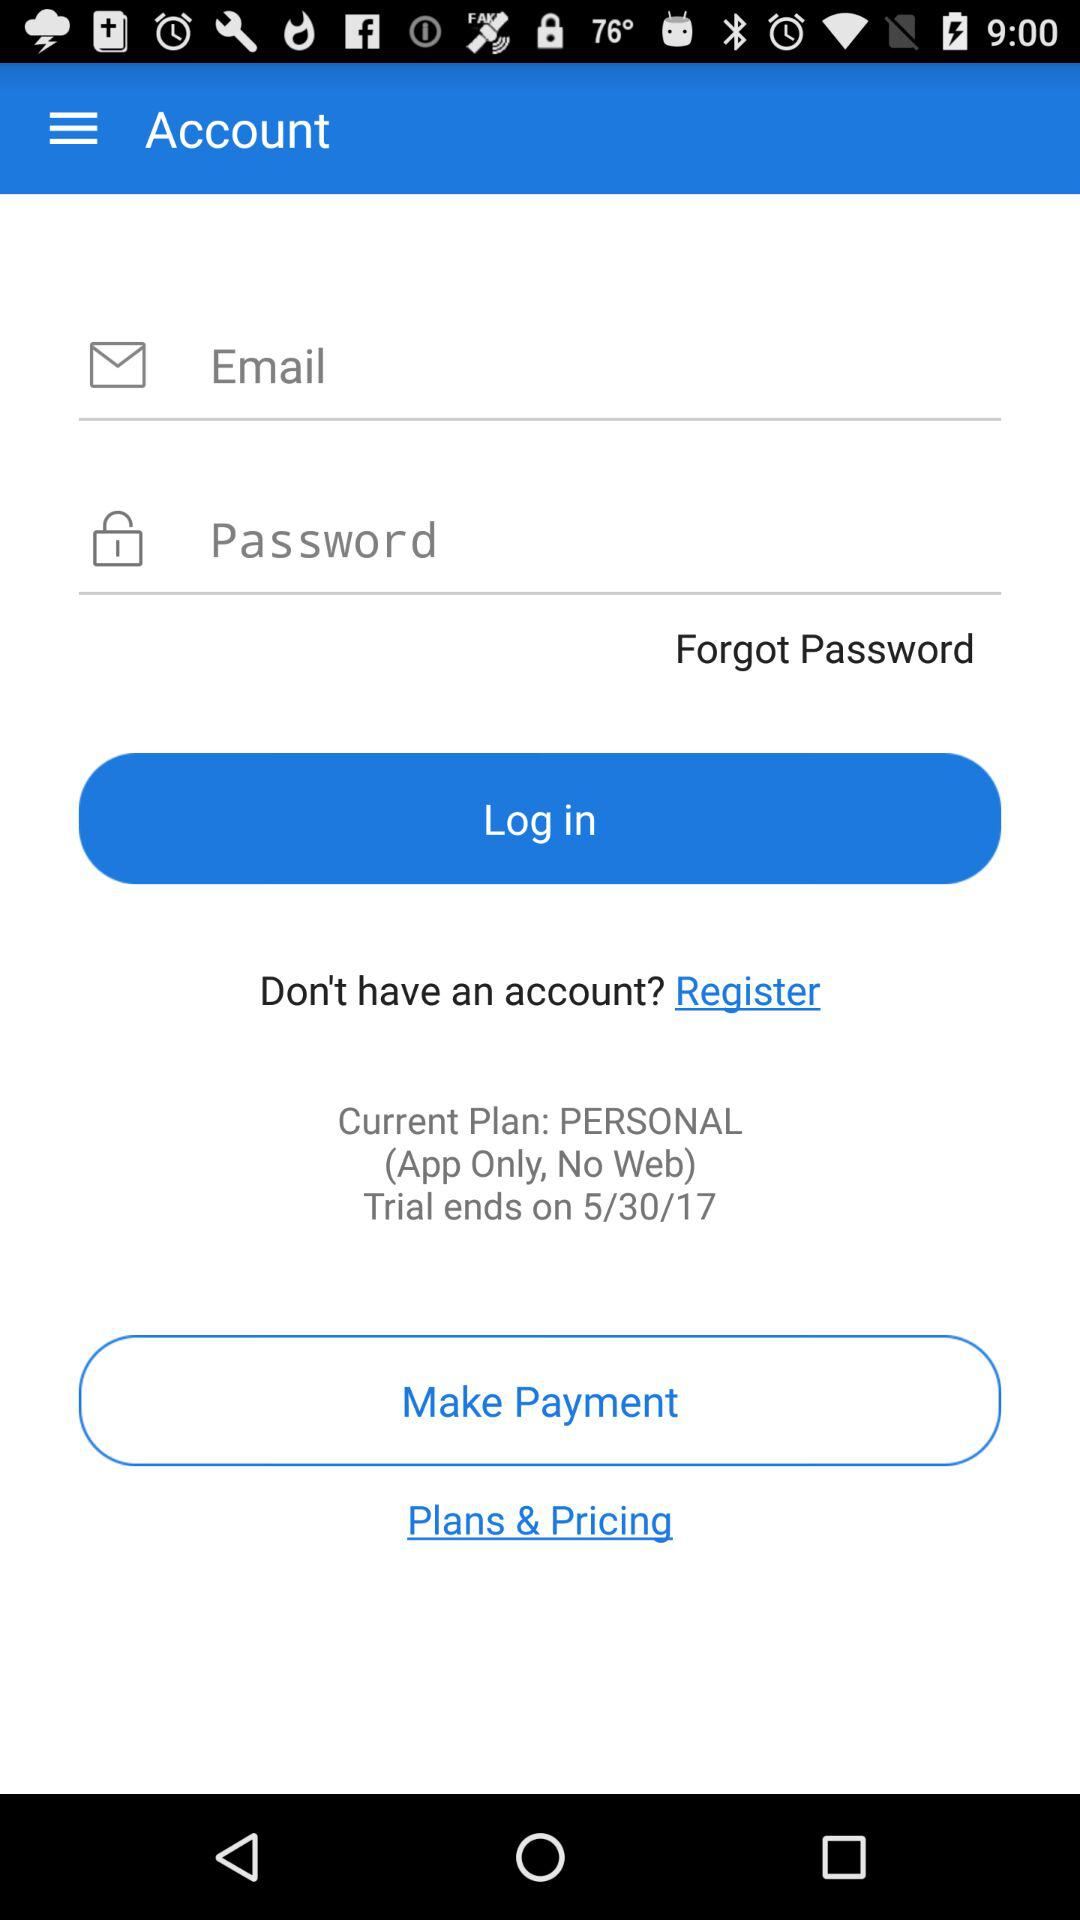When will the trial plan end? The trial plan will end on May 30, 2017. 